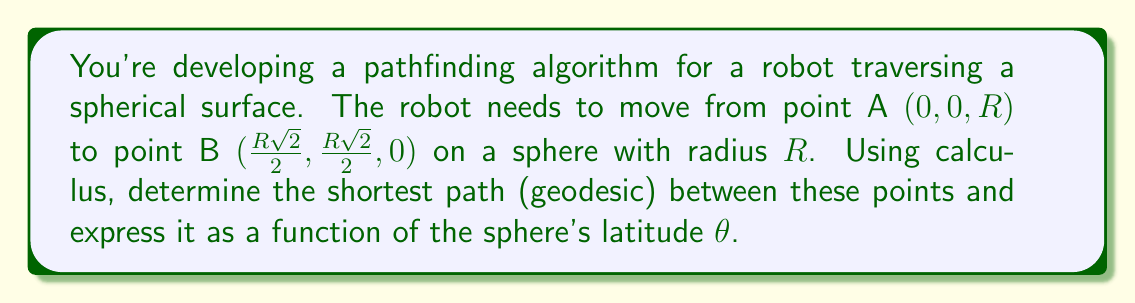What is the answer to this math problem? Let's approach this step-by-step:

1) On a sphere, the shortest path between two points is a great circle. We need to find the equation of this great circle.

2) We can parameterize the sphere using spherical coordinates:
   $$x = R \sin\theta \cos\phi$$
   $$y = R \sin\theta \sin\phi$$
   $$z = R \cos\theta$$

3) Point A is at $(0, 0, R)$, which corresponds to $\theta = 0$.
   Point B is at $(\frac{R\sqrt{2}}{2}, \frac{R\sqrt{2}}{2}, 0)$, which corresponds to $\theta = \frac{\pi}{2}$ and $\phi = \frac{\pi}{4}$.

4) The equation of the great circle passing through these points in spherical coordinates is:
   $$\tan\phi = \tan(\frac{\pi}{4})\sin\theta$$

5) To express this in Cartesian coordinates, we can use the relations:
   $$\tan\phi = \frac{y}{x}$$
   $$\sin\theta = \frac{\sqrt{x^2 + y^2}}{R}$$

6) Substituting these into the great circle equation:
   $$\frac{y}{x} = \frac{\sqrt{x^2 + y^2}}{R}$$

7) This can be simplified to:
   $$y = x$$

8) The shortest path (geodesic) can thus be expressed as a function of latitude $\theta$:
   $$x = y = \frac{R\sin\theta}{\sqrt{2}}$$
   $$z = R\cos\theta$$

This parameterization gives the coordinates of any point on the shortest path as a function of $\theta$, where $0 \leq \theta \leq \frac{\pi}{2}$.
Answer: $$x = y = \frac{R\sin\theta}{\sqrt{2}}, z = R\cos\theta, 0 \leq \theta \leq \frac{\pi}{2}$$ 